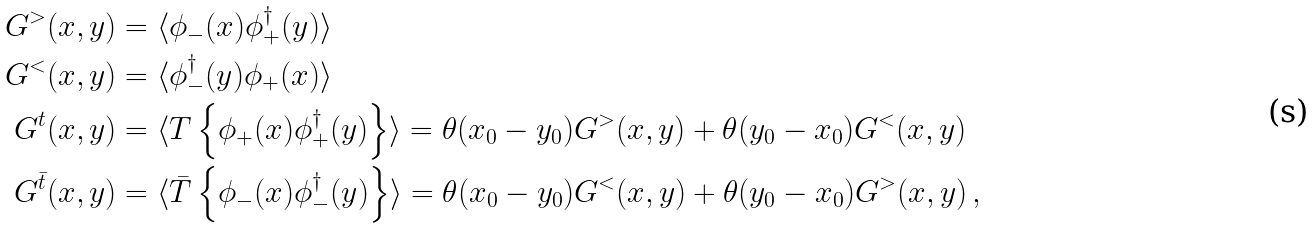Convert formula to latex. <formula><loc_0><loc_0><loc_500><loc_500>G ^ { > } ( x , y ) & = \langle \phi _ { - } ( x ) \phi _ { + } ^ { \dag } ( y ) \rangle \\ G ^ { < } ( x , y ) & = \langle \phi _ { - } ^ { \dag } ( y ) \phi _ { + } ( x ) \rangle \\ G ^ { t } ( x , y ) & = \langle T \left \{ \phi _ { + } ( x ) \phi _ { + } ^ { \dag } ( y ) \right \} \rangle = \theta ( x _ { 0 } - y _ { 0 } ) G ^ { > } ( x , y ) + \theta ( y _ { 0 } - x _ { 0 } ) G ^ { < } ( x , y ) \\ G ^ { \bar { t } } ( x , y ) & = \langle \bar { T } \left \{ \phi _ { - } ( x ) \phi _ { - } ^ { \dag } ( y ) \right \} \rangle = \theta ( x _ { 0 } - y _ { 0 } ) G ^ { < } ( x , y ) + \theta ( y _ { 0 } - x _ { 0 } ) G ^ { > } ( x , y ) \, ,</formula> 